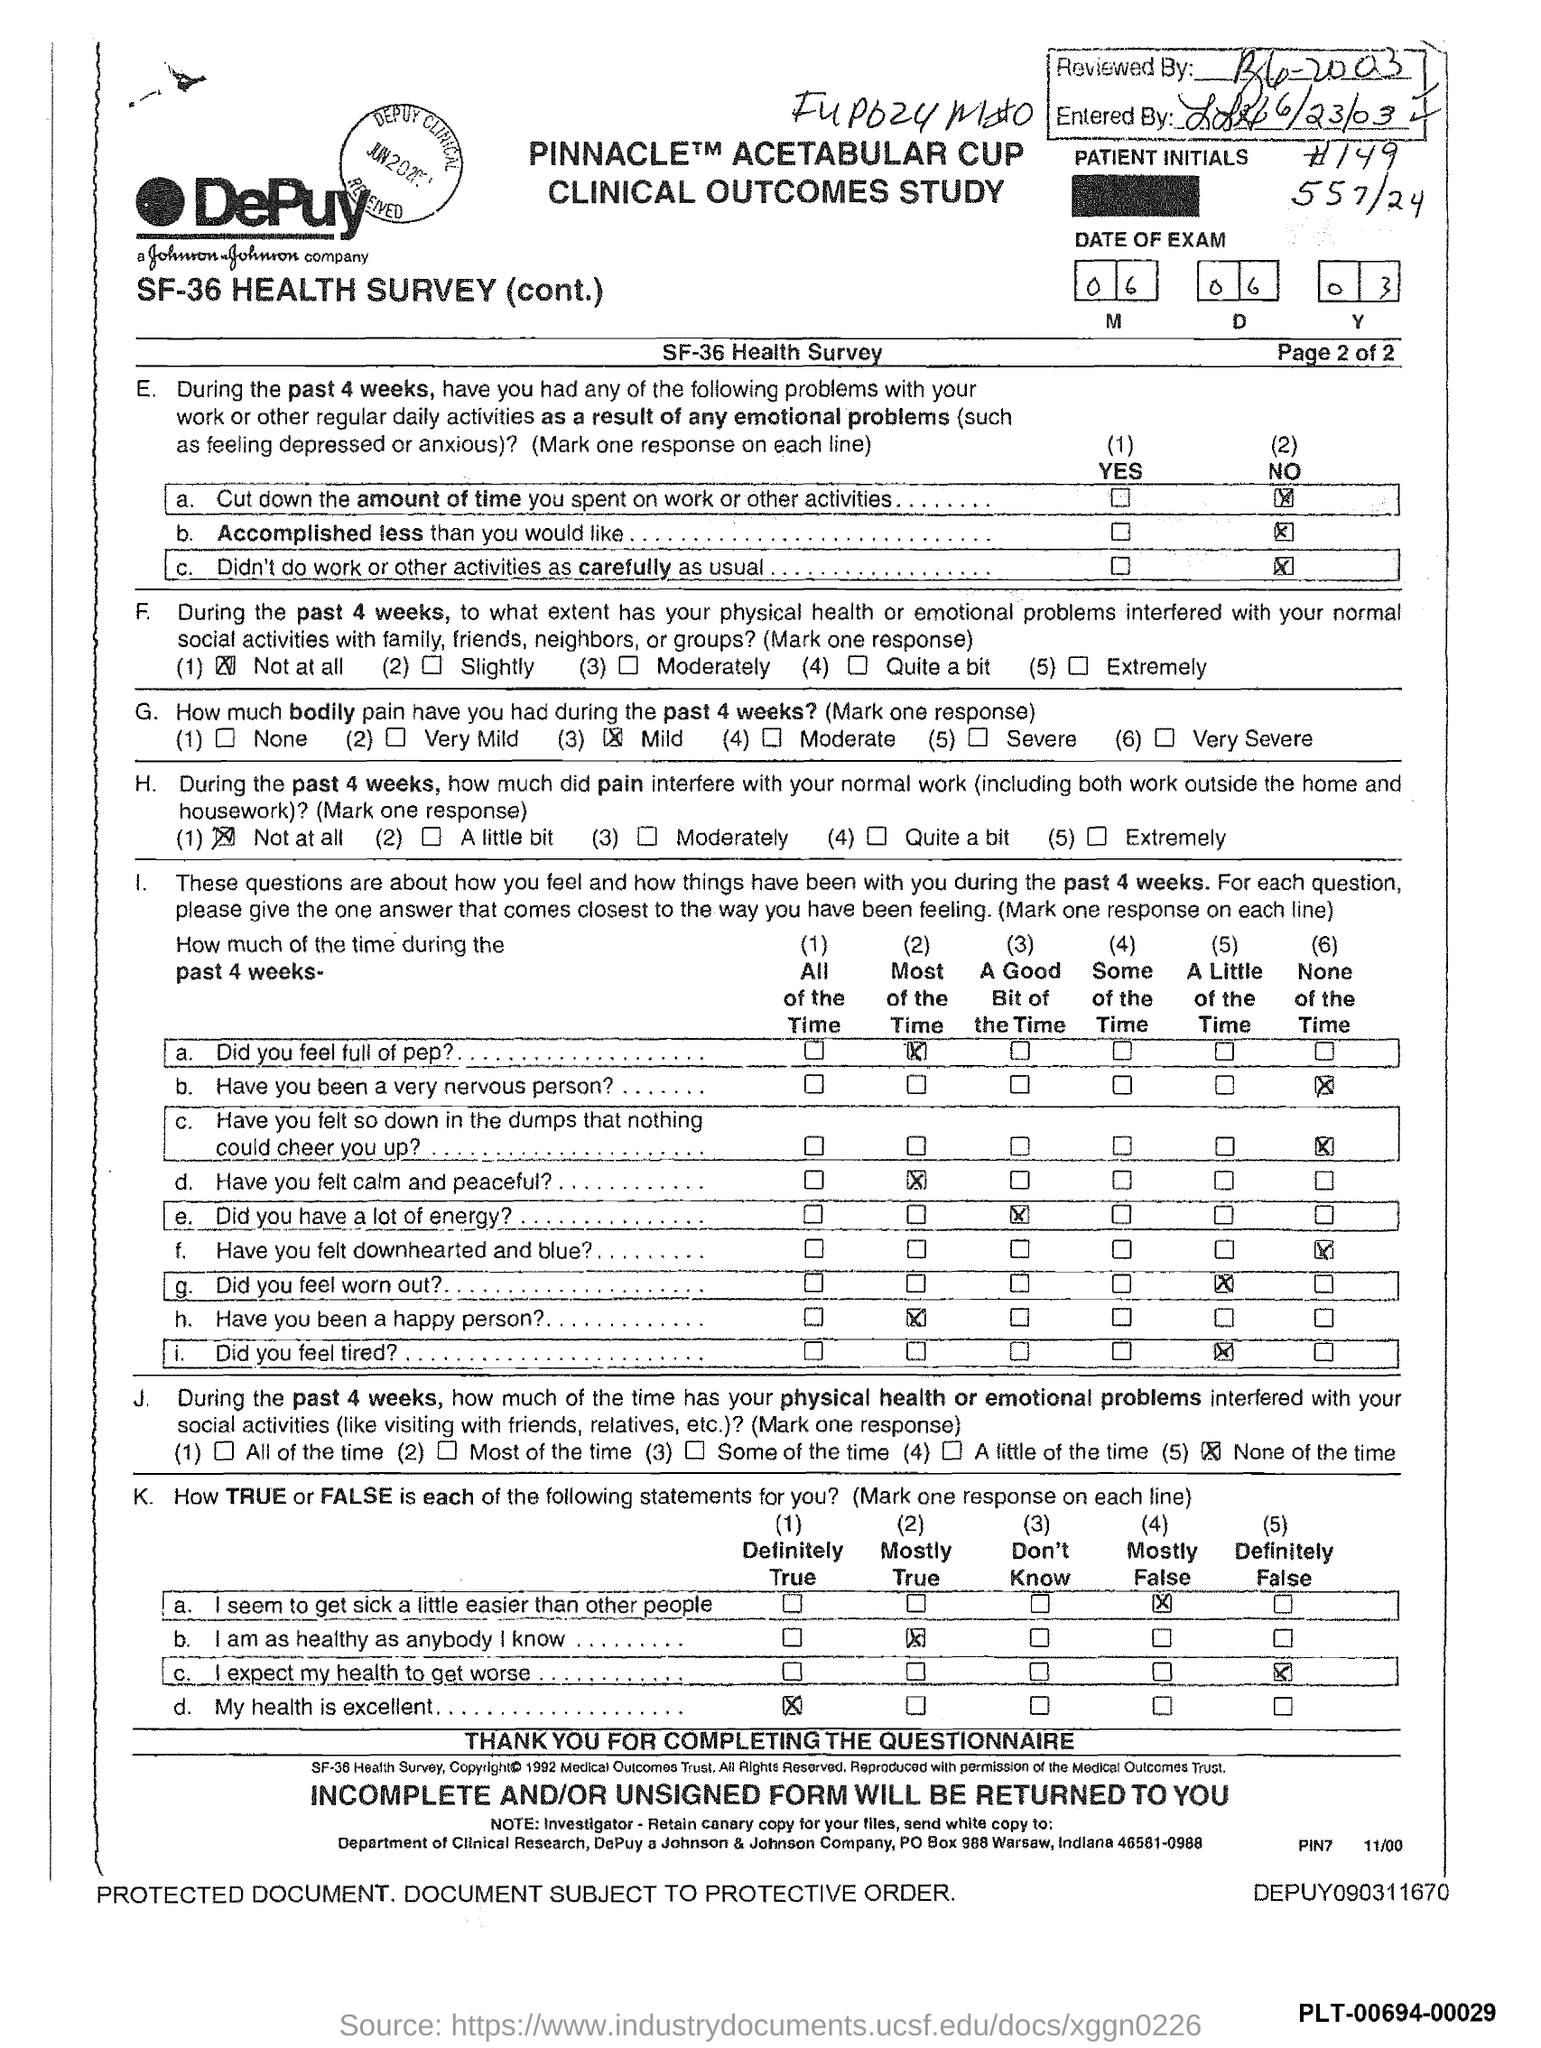Highlight a few significant elements in this photo. During the past 4 weeks, the individual has experienced mild bodily pain as per the health survey. The date of the exam mentioned in the document is June 6, 2003. 